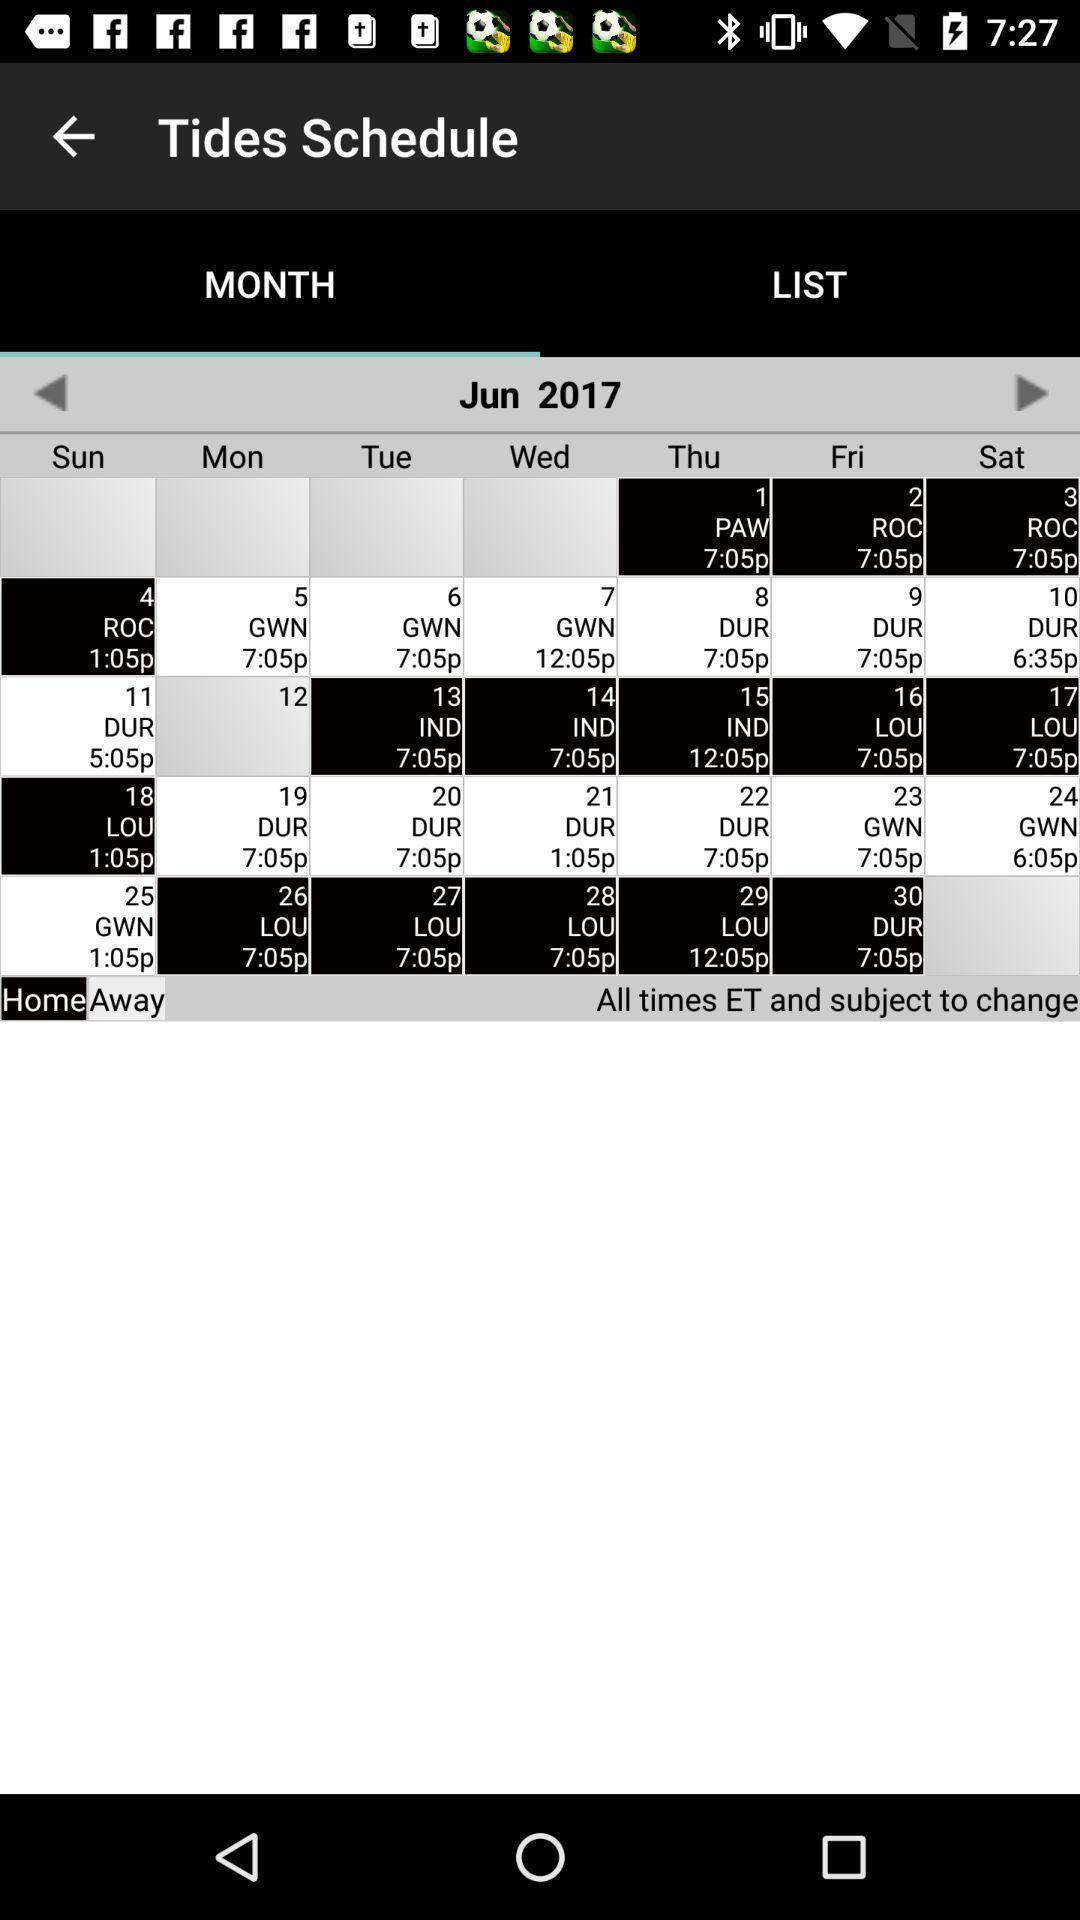Provide a description of this screenshot. Screen shows schedule page in sports application. 